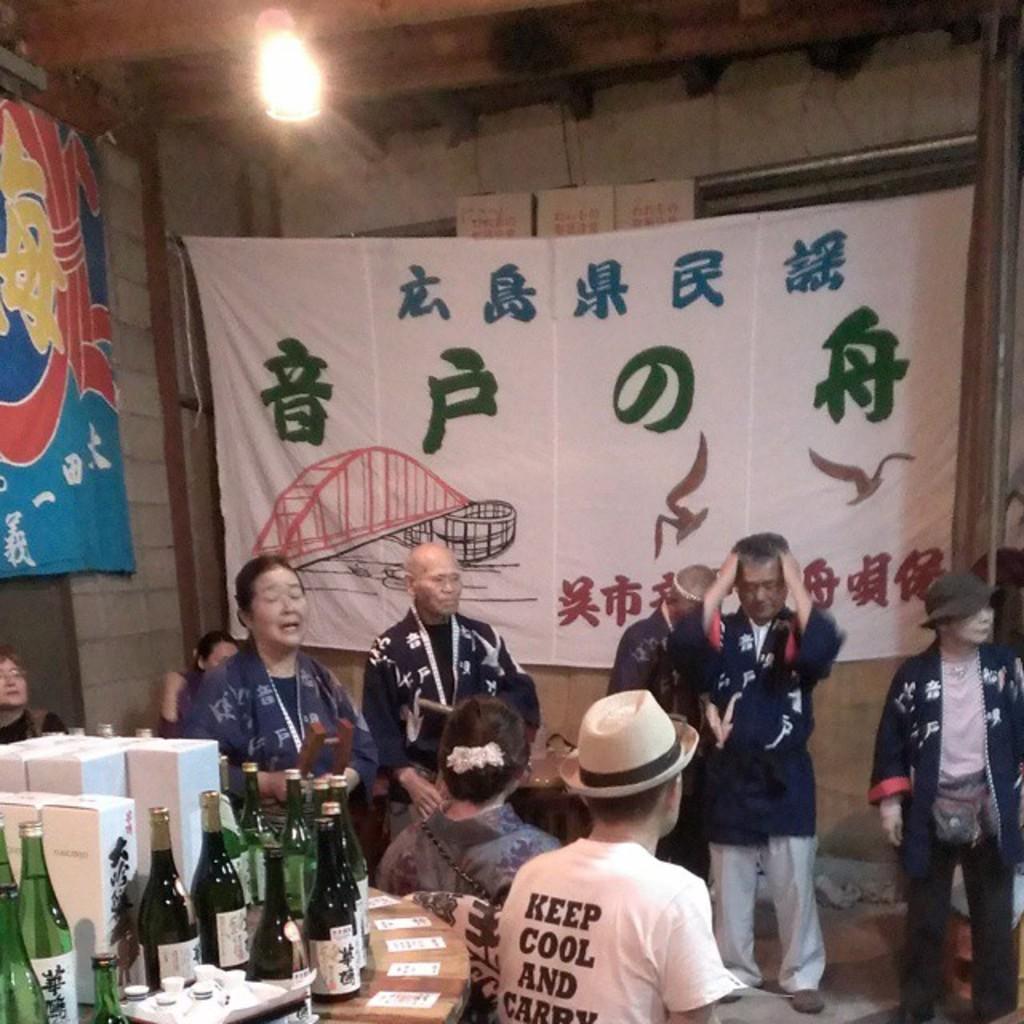How would you summarize this image in a sentence or two? In this image, there are few people standing and few people sitting. At the bottom left side of the image, there is a table with the bottle, cards and few other things on it. On the left side of the image, there is a banner hanging. At the top of the image, I can see a light. In the background, there is another banner hanging. 